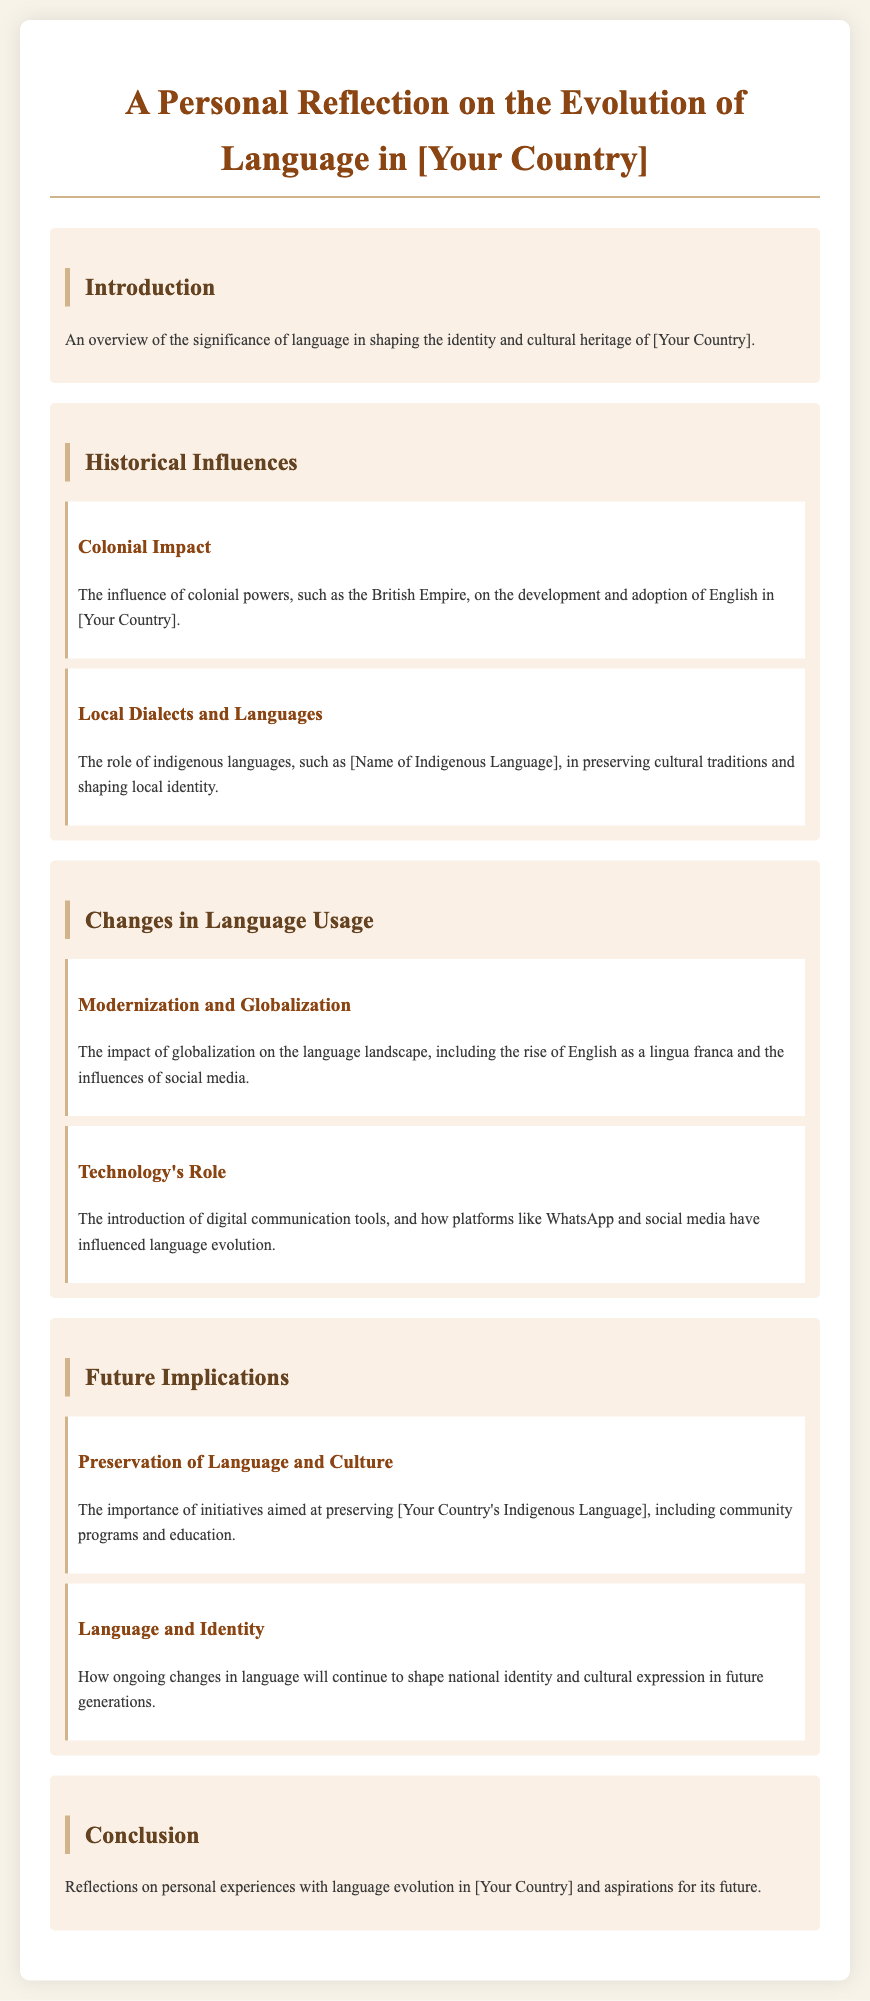What is the title of the document? The title is stated in the header of the document, presenting the main topic of the reflection.
Answer: A Personal Reflection on the Evolution of Language in [Your Country] What is mentioned as a historical influence on language in the document? The section on historical influences discusses the colonial impact and local dialects and languages.
Answer: Colonial Impact Which indigenous language is referenced in the document? The document includes a placeholder for an indigenous language, indicating its significance in cultural preservation.
Answer: [Name of Indigenous Language] What global phenomenon is discussed in relation to language usage? The document highlights how globalization affects language, notably the rise of English as a lingua franca.
Answer: Globalization What technology is noted for its role in language evolution? The impact of digital communication tools is noted, specifically mentioning platforms that influence language changes.
Answer: Technology Which future implication is emphasized for preserving languages? The importance of initiatives aimed at preserving the indigenous language through community programs is discussed in the future implications section.
Answer: Preservation of Language and Culture What personal aspect is reflected upon in the conclusion? The conclusion includes a personal reflection on experiences with language evolution in the specified country.
Answer: Personal experiences What cultural aspect is considered for the future generations? The document discusses how changes in language will impact national identity and cultural expression in future generations.
Answer: Language and Identity 